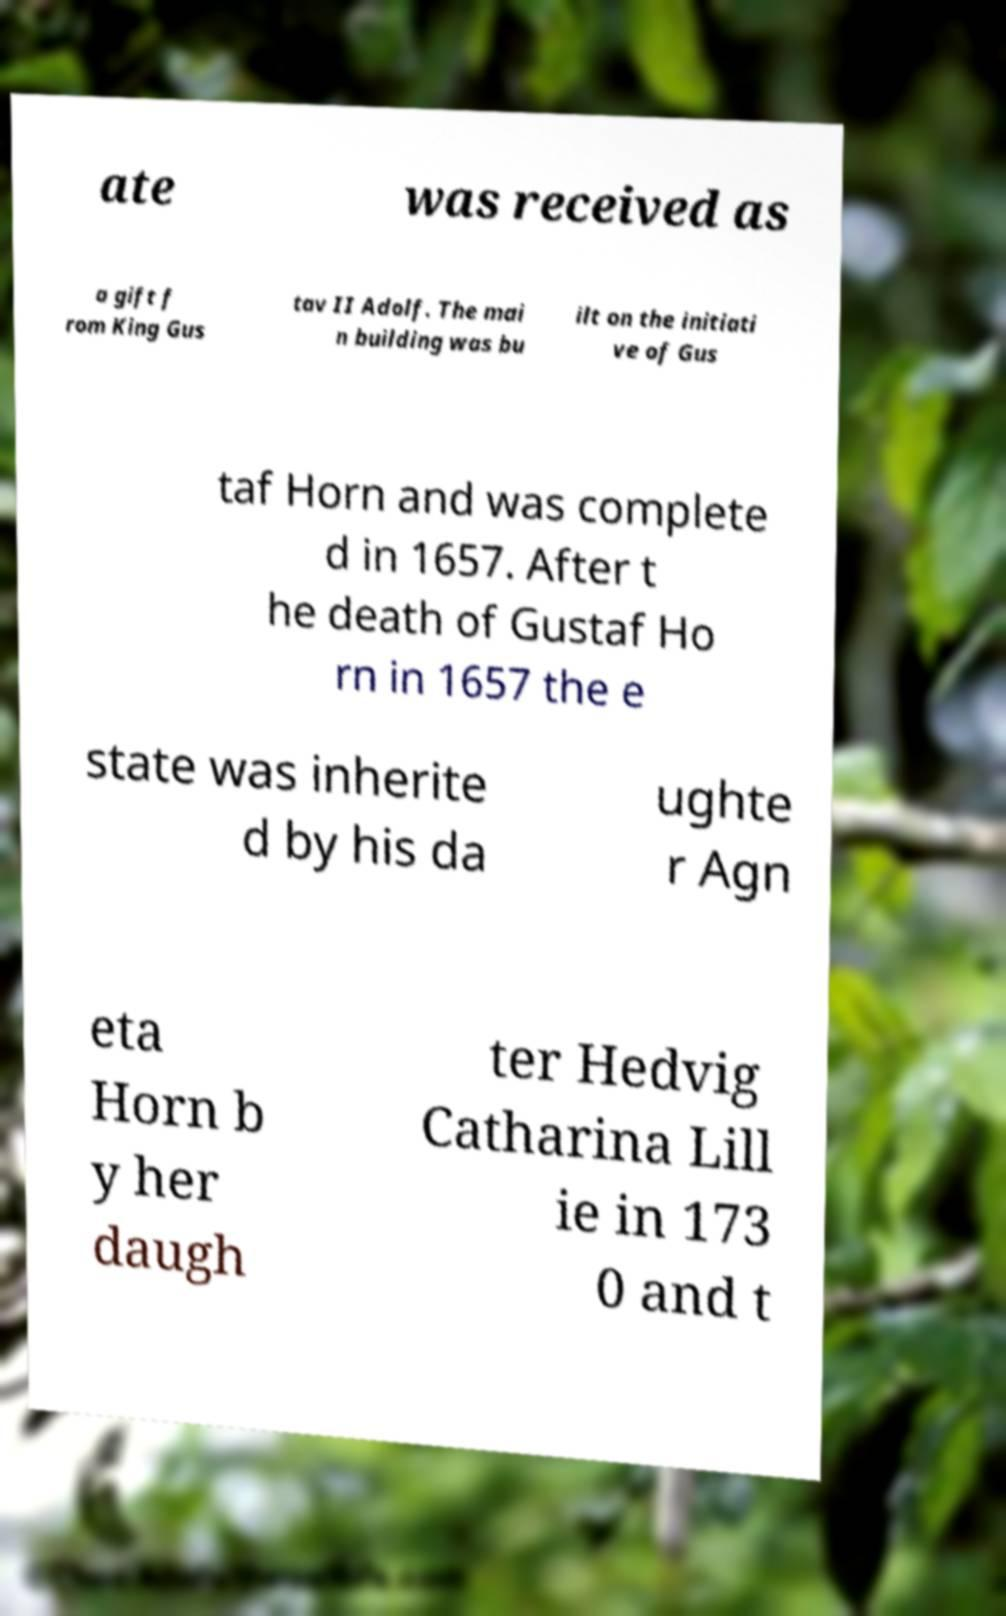Please read and relay the text visible in this image. What does it say? ate was received as a gift f rom King Gus tav II Adolf. The mai n building was bu ilt on the initiati ve of Gus taf Horn and was complete d in 1657. After t he death of Gustaf Ho rn in 1657 the e state was inherite d by his da ughte r Agn eta Horn b y her daugh ter Hedvig Catharina Lill ie in 173 0 and t 